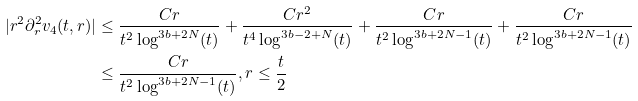Convert formula to latex. <formula><loc_0><loc_0><loc_500><loc_500>| r ^ { 2 } \partial _ { r } ^ { 2 } v _ { 4 } ( t , r ) | & \leq \frac { C r } { t ^ { 2 } \log ^ { 3 b + 2 N } ( t ) } + \frac { C r ^ { 2 } } { t ^ { 4 } \log ^ { 3 b - 2 + N } ( t ) } + \frac { C r } { t ^ { 2 } \log ^ { 3 b + 2 N - 1 } ( t ) } + \frac { C r } { t ^ { 2 } \log ^ { 3 b + 2 N - 1 } ( t ) } \\ & \leq \frac { C r } { t ^ { 2 } \log ^ { 3 b + 2 N - 1 } ( t ) } , r \leq \frac { t } { 2 }</formula> 